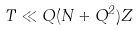Convert formula to latex. <formula><loc_0><loc_0><loc_500><loc_500>T \ll Q ( N + Q ^ { 2 } ) Z</formula> 